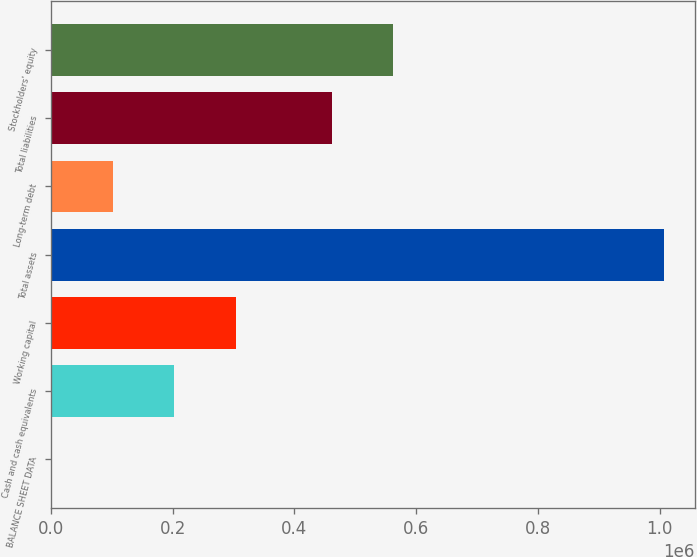<chart> <loc_0><loc_0><loc_500><loc_500><bar_chart><fcel>BALANCE SHEET DATA<fcel>Cash and cash equivalents<fcel>Working capital<fcel>Total assets<fcel>Long-term debt<fcel>Total liabilities<fcel>Stockholders' equity<nl><fcel>2009<fcel>203033<fcel>303545<fcel>1.00713e+06<fcel>102521<fcel>461502<fcel>562014<nl></chart> 